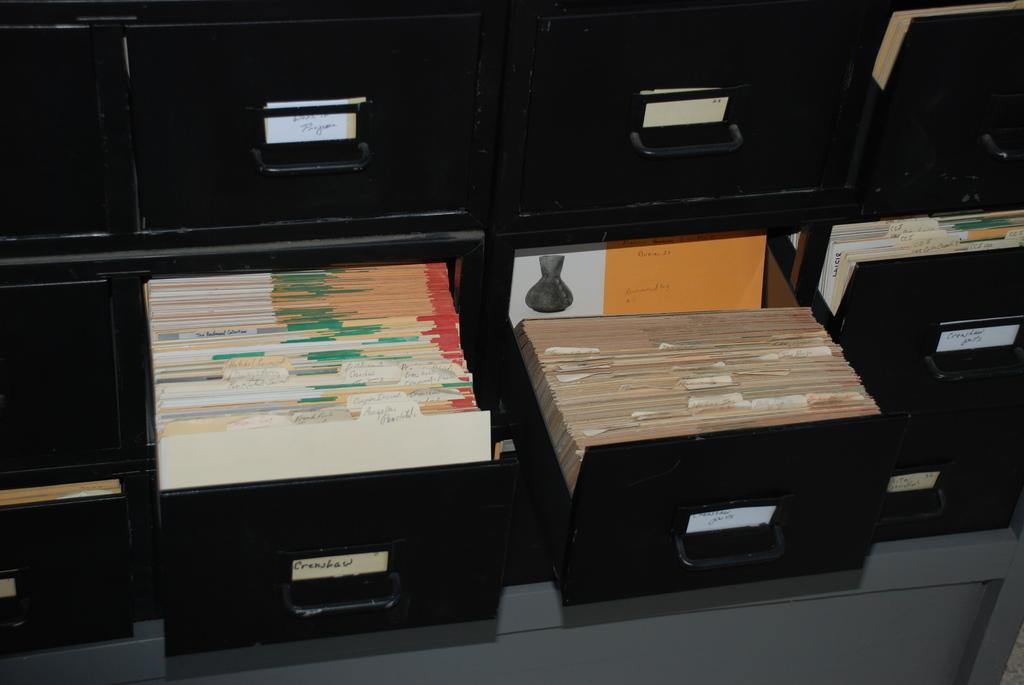What type of furniture is visible in the image? There are drawers in the image. What is the color of the drawers? The drawers are black in color. What can be found inside the drawers? There are objects in the drawers. What colors are the objects inside the drawers? The objects are white and brown in color. What type of discussion is taking place in the image? There is no discussion taking place in the image; it only shows drawers with objects inside. 